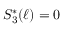<formula> <loc_0><loc_0><loc_500><loc_500>S _ { 3 } ^ { * } ( \ell ) = 0</formula> 